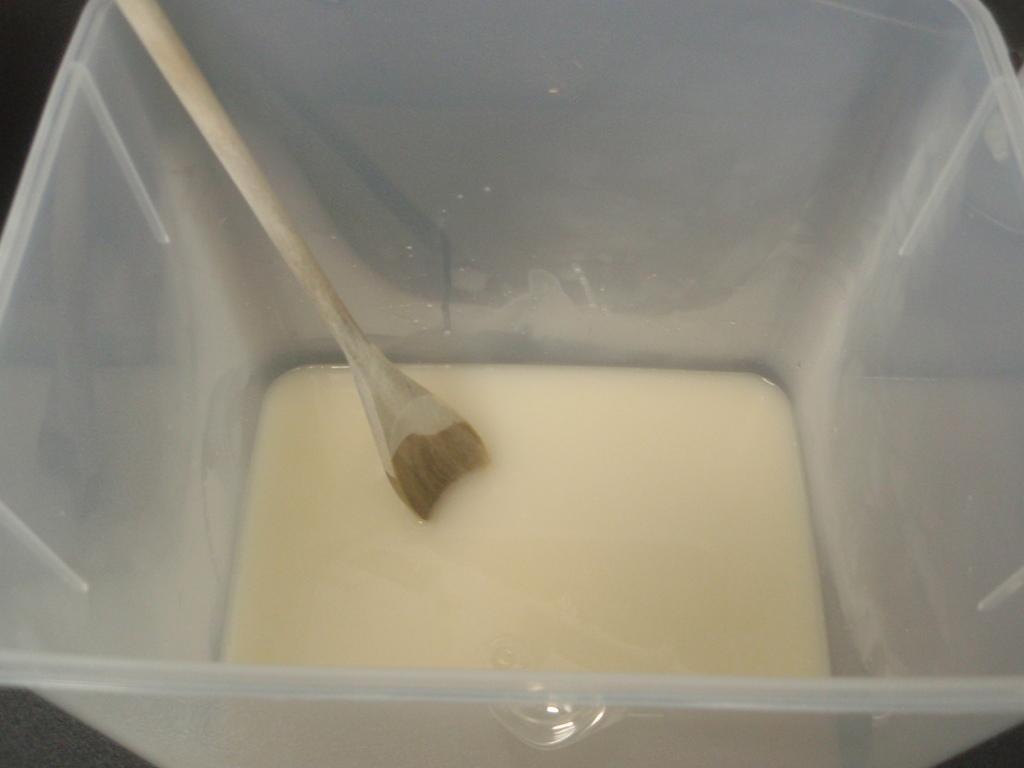Could you give a brief overview of what you see in this image? In this image we can see there is a liquid and a spoon placed in the plastic box. 